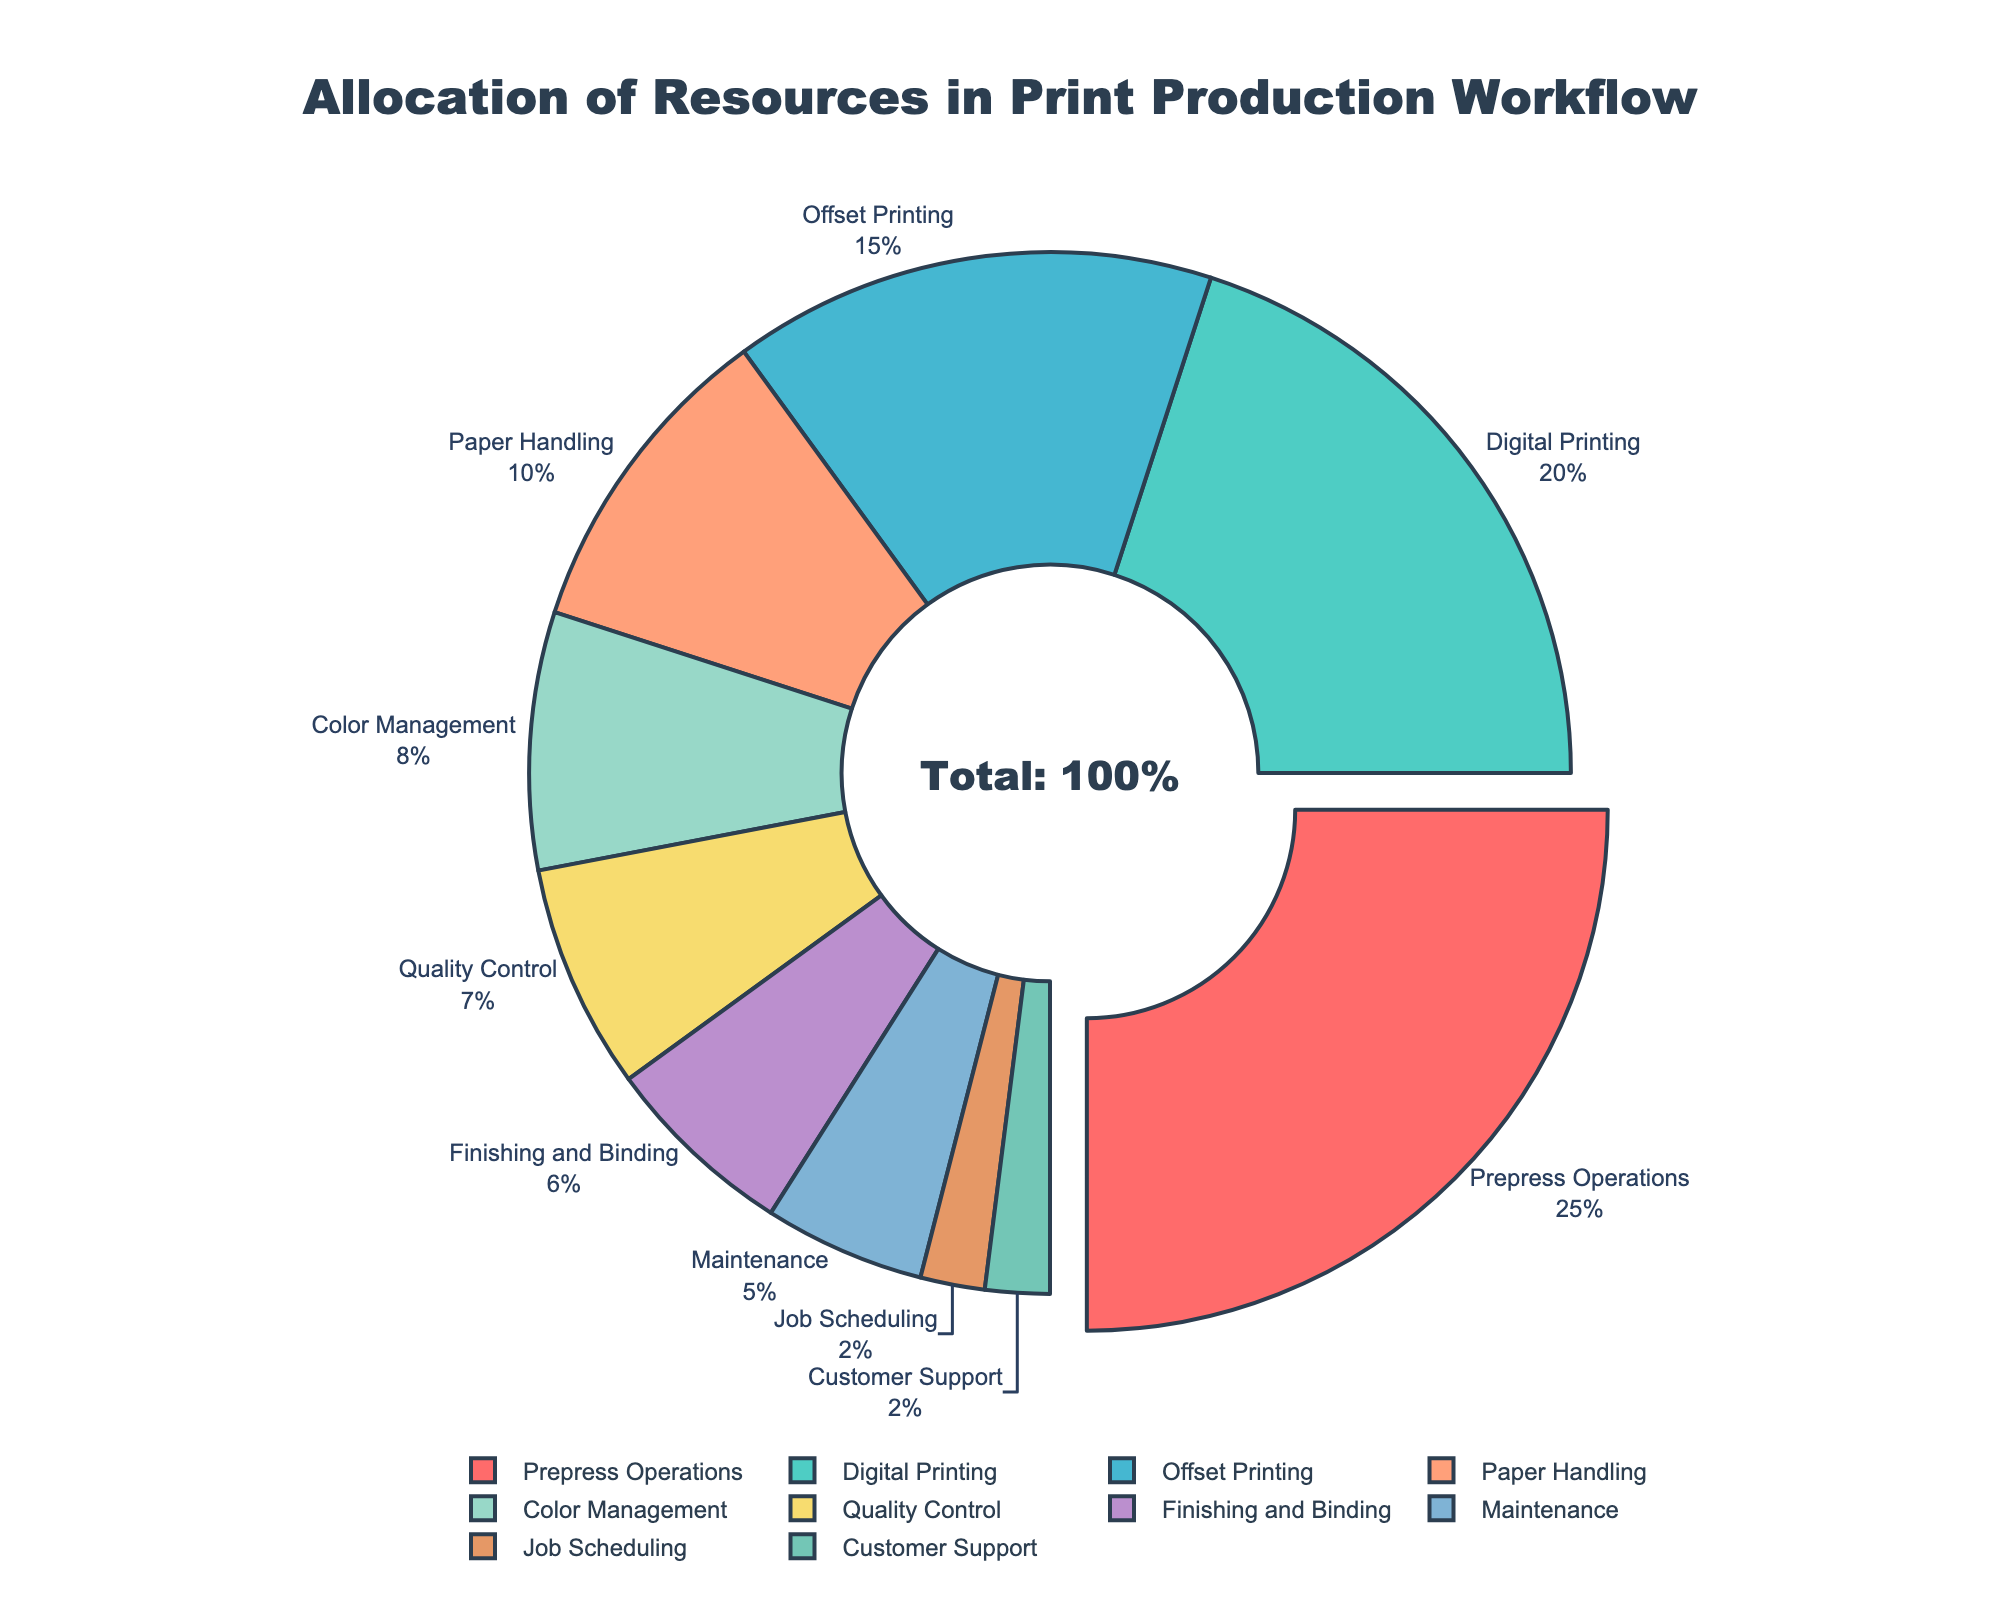What is the resource with the largest allocation percentage? By looking at the pie chart, we can see that "Prepress Operations" has the largest segment. The label shows "25%", which is the highest percentage among all categories.
Answer: Prepress Operations How much more percentage is allocated to Digital Printing compared to Maintenance? Digital Printing is allocated 20%, and Maintenance is allocated 5%. The difference is 20% - 5% = 15%.
Answer: 15% Which resources have the smallest allocation percentages? The pie chart shows that "Job Scheduling" and "Customer Support" both have labels with 2%. These are the smallest percentages in the chart.
Answer: Job Scheduling and Customer Support What is the combined allocation percentage for Quality Control and Finishing and Binding? Quality Control has 7%, and Finishing and Binding have 6%. The combined total is 7% + 6% = .13%.
Answer: 13% How many resources have an allocation percentage greater than 10%? Resources with more than 10% allocation are "Prepress Operations" (25%), "Digital Printing" (20%), and "Offset Printing" (15%). That makes a total of three resources.
Answer: 3 Which color is used to represent Paper Handling in the pie chart? According to the visual attributes of the pie chart, the segment for "Paper Handling" is colored in orange.
Answer: Orange What is the difference in percentage between Color Management and Customer Support? Color Management has 8%, and Customer Support has 2%. The difference is 8% - 2% = 6%.
Answer: 6% Are the resources Finishing and Binding and Maintenance allocated equally? By looking at the pie chart, we see that Finishing and Binding has 6%, and Maintenance has 5%. They are not allocated equally.
Answer: No What is the total percentage allocation for Paper Handling, Color Management, and Customer Support combined? Paper Handling is 10%, Color Management is 8%, and Customer Support is 2%. The total is 10% + 8% + 2% = 20%.
Answer: 20% Which resource has the second largest allocation? The second largest segment after "Prepress Operations" is for "Digital Printing" which is labeled 20%.
Answer: Digital Printing 